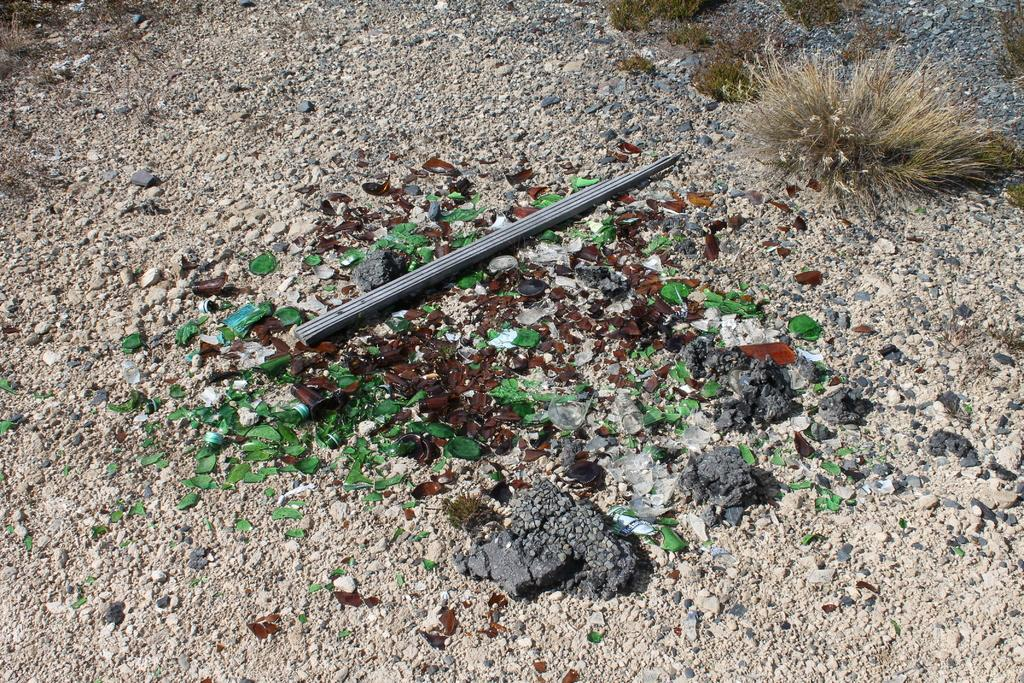What is the main object in the image? There is a wooden stick in the image. What is the wooden stick placed on? The wooden stick is on glass pieces and stones. What is the wooden stick's proximity to? The wooden stick is near dry grass. What can be seen in the background of the image? There is grass and stones on the ground in the background. How many feet are visible in the image? There are no feet visible in the image. What type of weather can be inferred from the image? The image does not provide any information about the weather. 